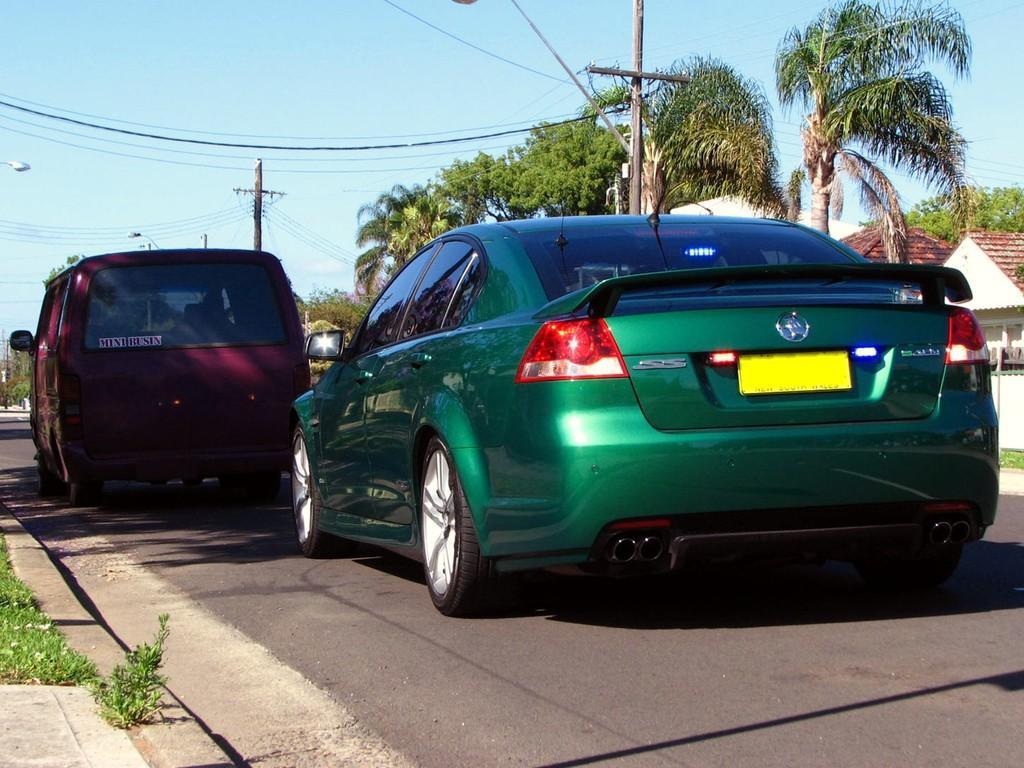Could you give a brief overview of what you see in this image? In this picture, we see the vehicles in purple and green color are moving on the road. At the bottom of the picture, we see the road and the grass. There are electric poles, wires, trees and buildings in the background. At the top of the picture, we see the sky. This picture is clicked outside the city. 